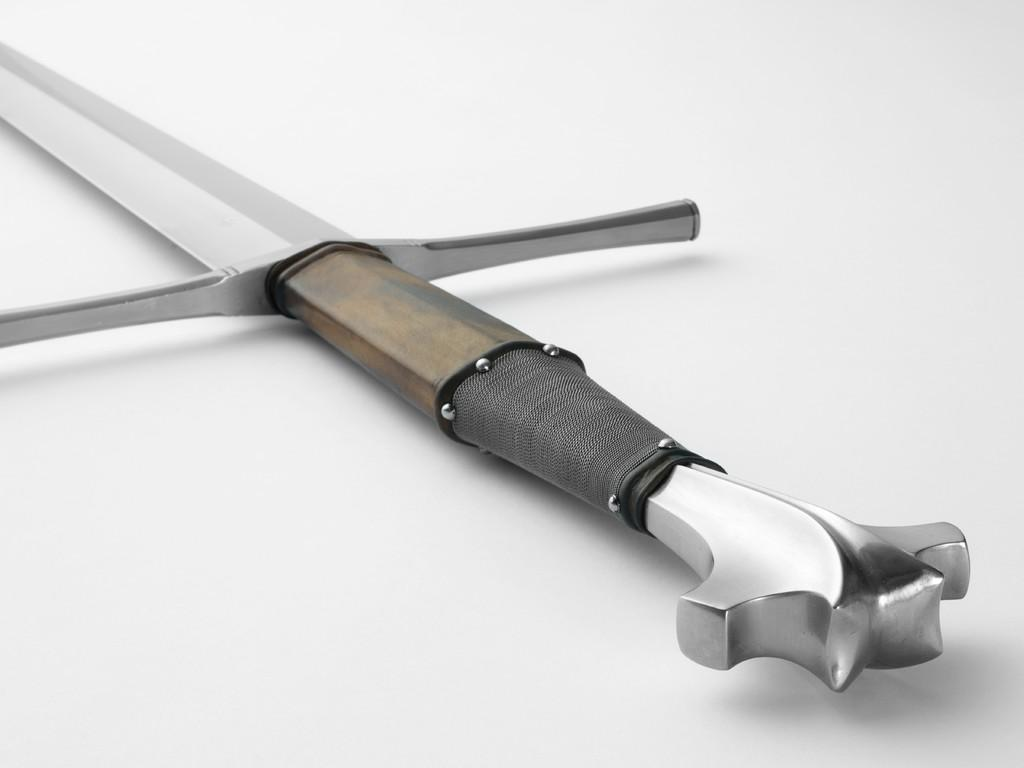What object is present in the image? There is a sword in the image. Where is the sword located? The sword is on a surface. What word is written on the sword in the image? There is no word written on the sword in the image. What type of apparel is the sword wearing in the image? Swords do not wear apparel, as they are inanimate objects. 